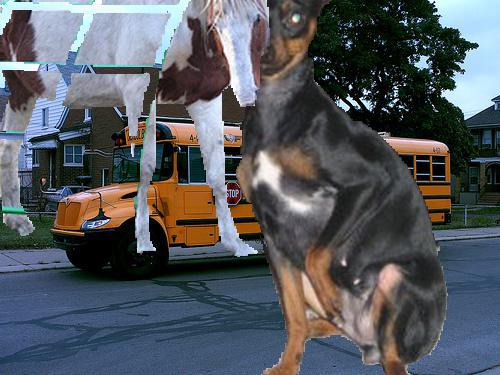Would there be a bus in the image after the bus disappeared from this picture? No, once the bus has disappeared from the picture, it would no longer be visible within the frame. The scene would then likely include just the street, the houses, and any remaining objects or beings, such as the dog in the foreground. 